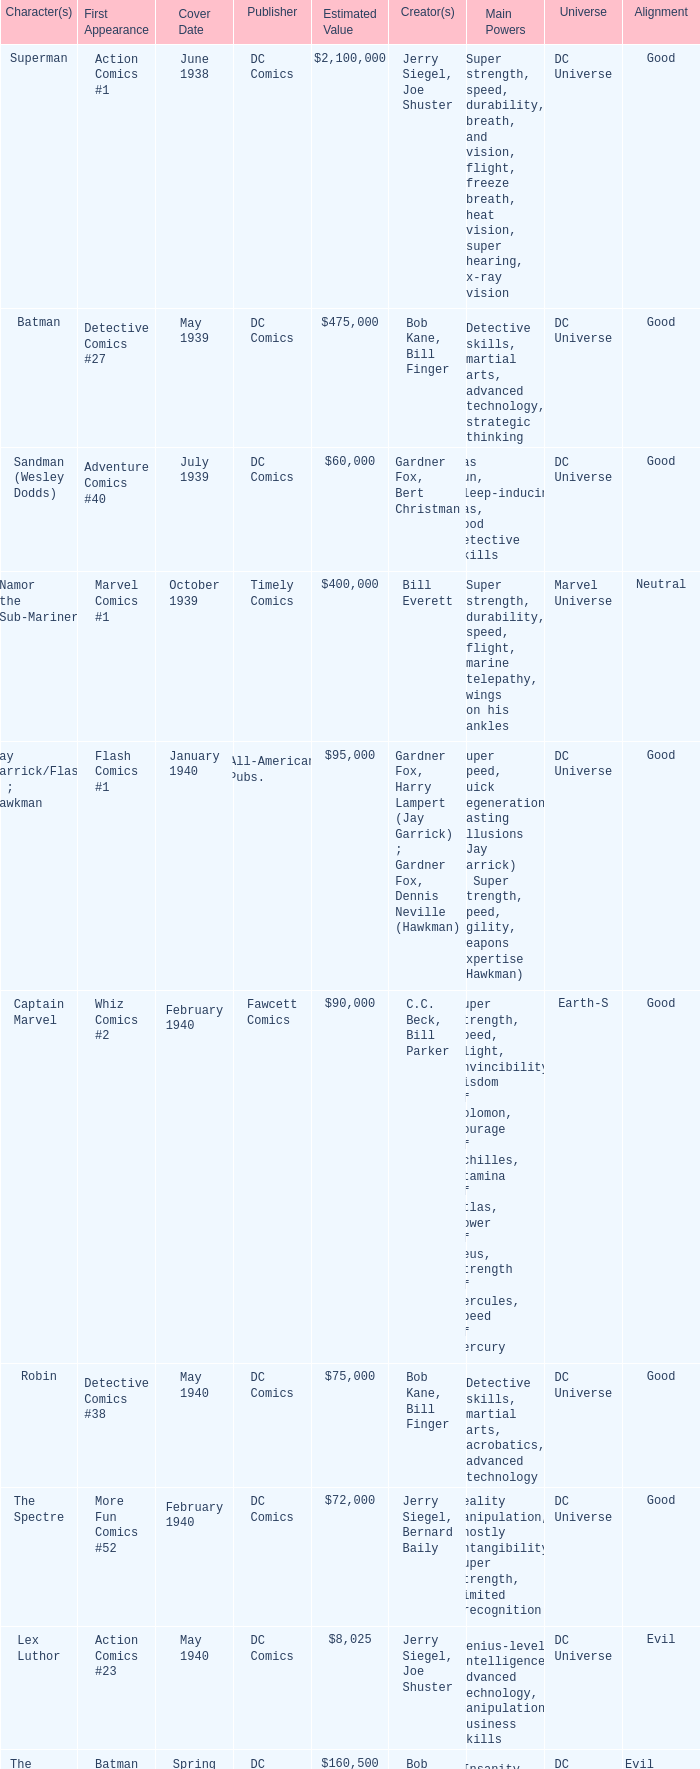Which character first appeared in Amazing Fantasy #15? Spider-Man. 